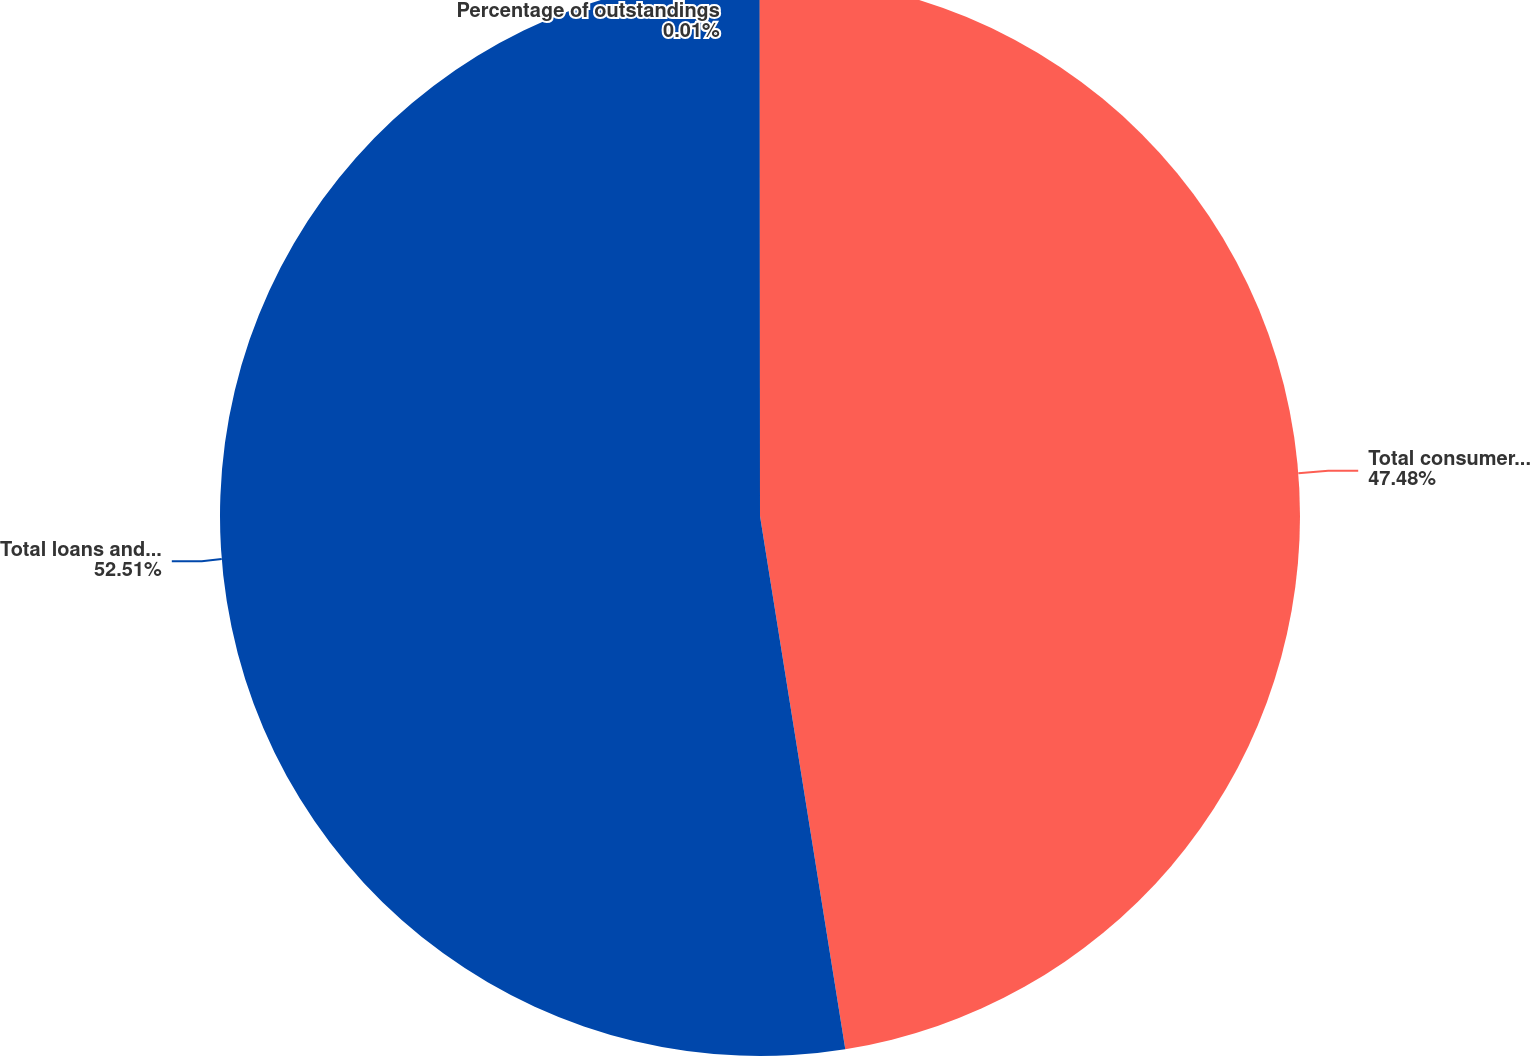Convert chart. <chart><loc_0><loc_0><loc_500><loc_500><pie_chart><fcel>Total consumer loans and<fcel>Total loans and leases<fcel>Percentage of outstandings<nl><fcel>47.48%<fcel>52.52%<fcel>0.01%<nl></chart> 